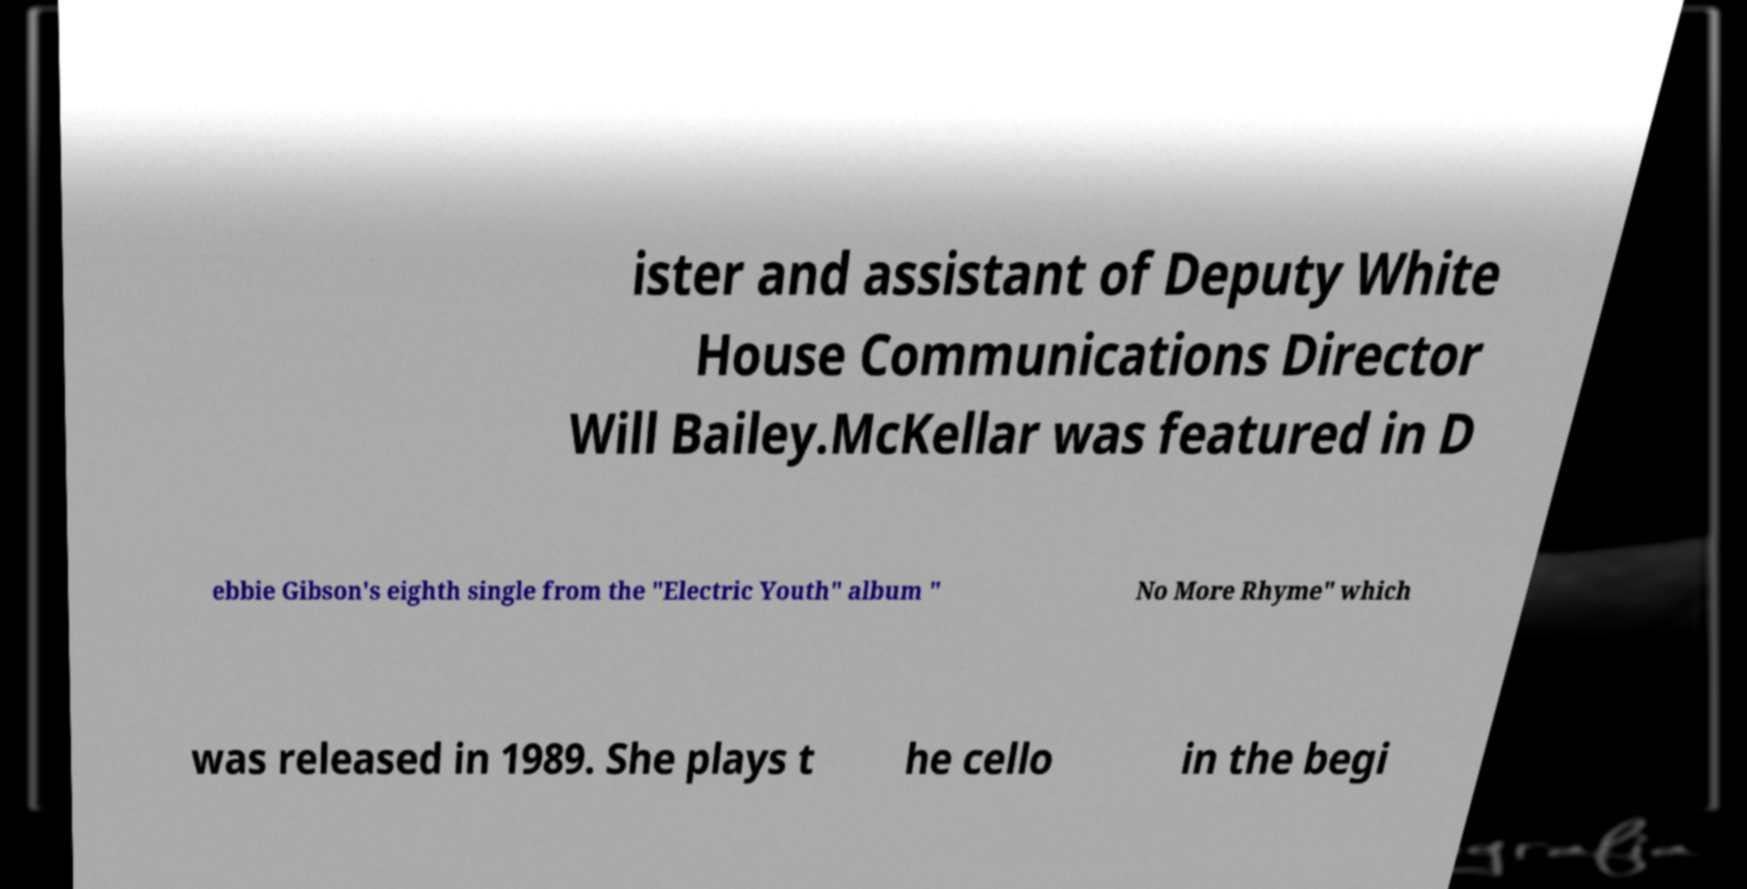Can you accurately transcribe the text from the provided image for me? ister and assistant of Deputy White House Communications Director Will Bailey.McKellar was featured in D ebbie Gibson's eighth single from the "Electric Youth" album " No More Rhyme" which was released in 1989. She plays t he cello in the begi 